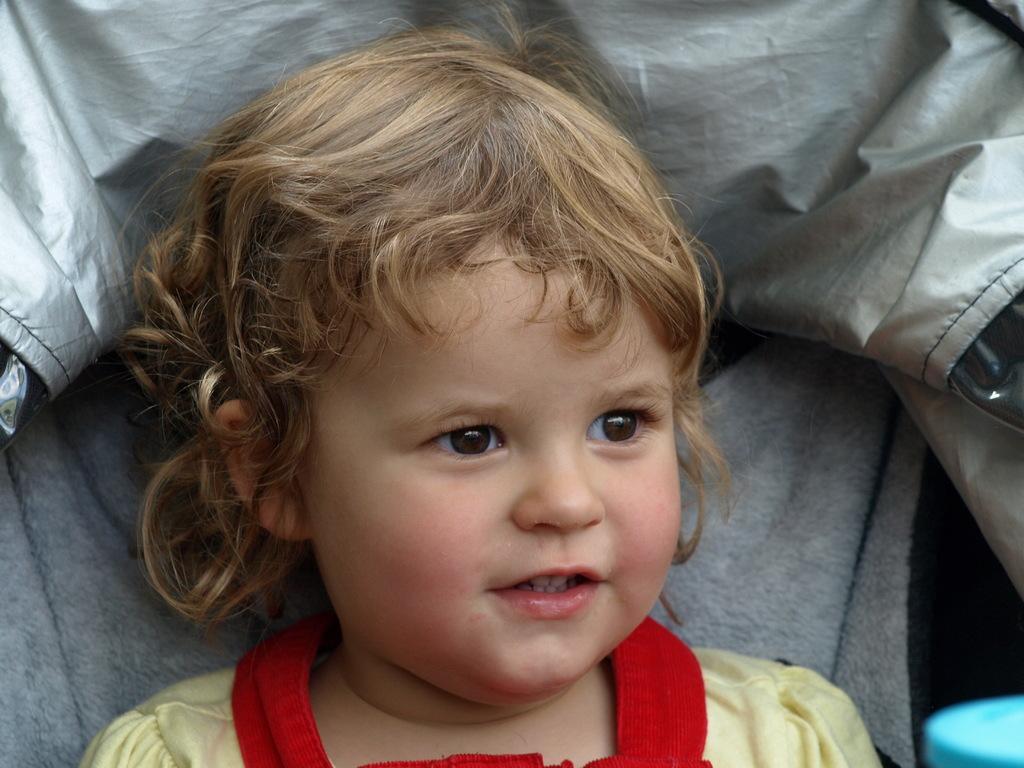How would you summarize this image in a sentence or two? In this image we can see a baby wearing red and yellow color dress, a blue color object and in the background there is an ash color cloth. 